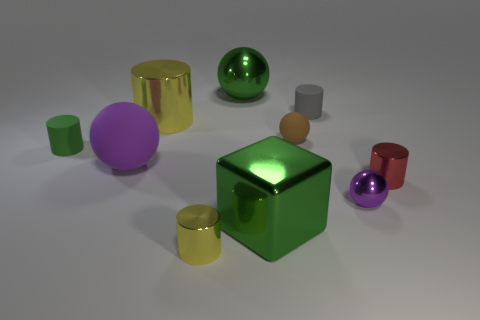What is the material of the cylinder that is the same color as the big metallic block?
Your answer should be very brief. Rubber. How many things are either tiny gray objects or matte objects that are left of the tiny purple thing?
Offer a terse response. 4. Are there any other things that have the same shape as the tiny green object?
Ensure brevity in your answer.  Yes. There is a purple sphere that is right of the purple matte ball; is its size the same as the purple rubber sphere?
Keep it short and to the point. No. What number of rubber things are either tiny purple balls or small yellow objects?
Make the answer very short. 0. There is a green metal object that is in front of the big green metallic sphere; what size is it?
Offer a terse response. Large. Are there an equal number of small green metal things and big matte objects?
Keep it short and to the point. No. Is the big matte thing the same shape as the small green object?
Provide a succinct answer. No. How many large objects are green cylinders or purple matte objects?
Provide a succinct answer. 1. There is a red cylinder; are there any red metal cylinders behind it?
Your answer should be very brief. No. 